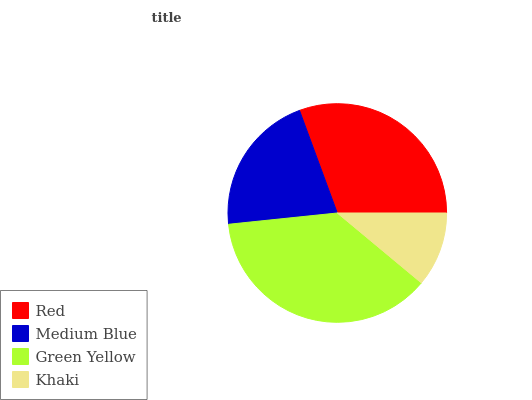Is Khaki the minimum?
Answer yes or no. Yes. Is Green Yellow the maximum?
Answer yes or no. Yes. Is Medium Blue the minimum?
Answer yes or no. No. Is Medium Blue the maximum?
Answer yes or no. No. Is Red greater than Medium Blue?
Answer yes or no. Yes. Is Medium Blue less than Red?
Answer yes or no. Yes. Is Medium Blue greater than Red?
Answer yes or no. No. Is Red less than Medium Blue?
Answer yes or no. No. Is Red the high median?
Answer yes or no. Yes. Is Medium Blue the low median?
Answer yes or no. Yes. Is Khaki the high median?
Answer yes or no. No. Is Khaki the low median?
Answer yes or no. No. 